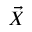Convert formula to latex. <formula><loc_0><loc_0><loc_500><loc_500>\vec { X }</formula> 